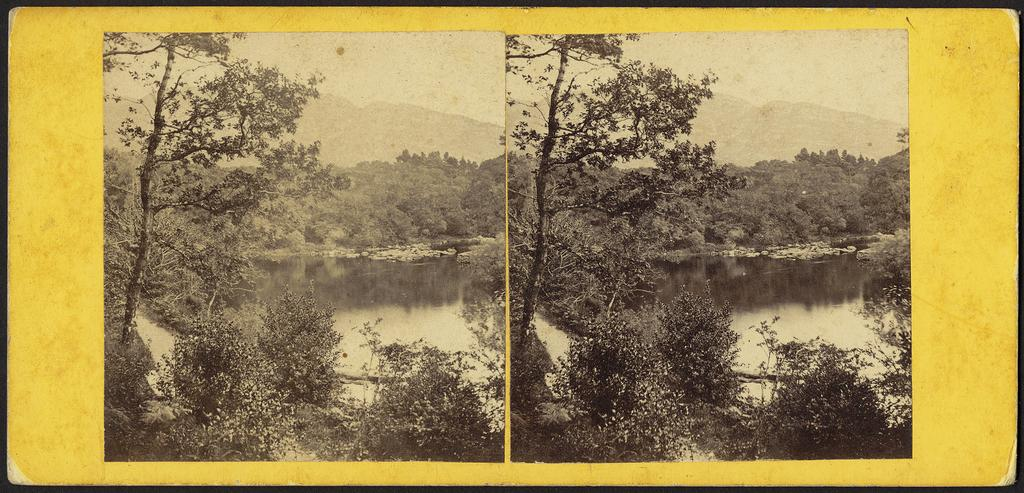How has the image been altered or modified? The image is edited. What can be seen on the paper in the image? There are two pictures posted on some paper. What is located in the middle of the image? There is water and trees in the middle of the image. What is visible at the top of the image? The sky is visible at the top of the image. What type of error can be seen in the image? There is no error present in the image; it is simply edited with two pictures posted on some paper, water and trees in the middle, and sky visible at the top. Can you tell me how many tanks are visible in the image? There are no tanks present in the image. 